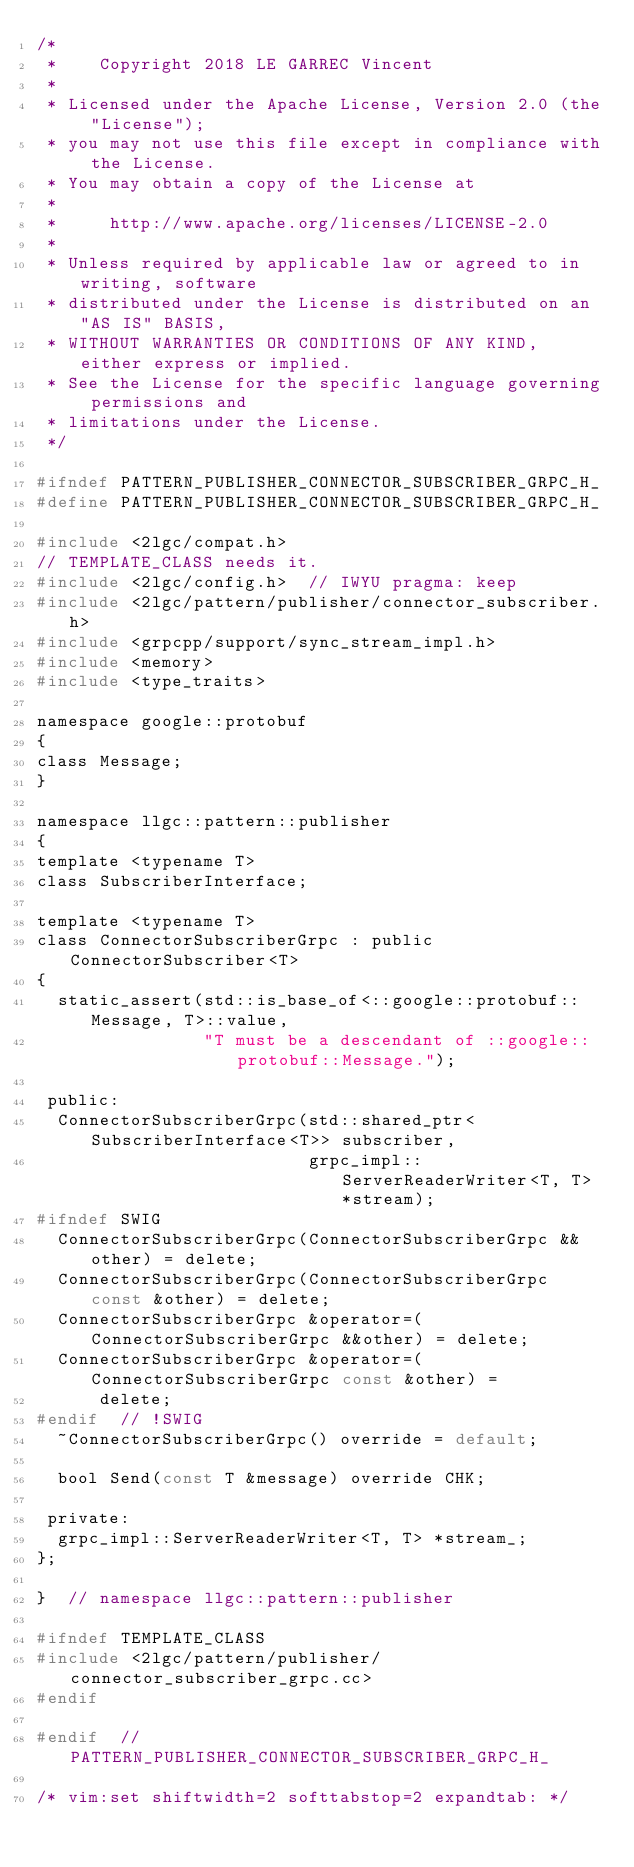<code> <loc_0><loc_0><loc_500><loc_500><_C_>/*
 *    Copyright 2018 LE GARREC Vincent
 *
 * Licensed under the Apache License, Version 2.0 (the "License");
 * you may not use this file except in compliance with the License.
 * You may obtain a copy of the License at
 *
 *     http://www.apache.org/licenses/LICENSE-2.0
 *
 * Unless required by applicable law or agreed to in writing, software
 * distributed under the License is distributed on an "AS IS" BASIS,
 * WITHOUT WARRANTIES OR CONDITIONS OF ANY KIND, either express or implied.
 * See the License for the specific language governing permissions and
 * limitations under the License.
 */

#ifndef PATTERN_PUBLISHER_CONNECTOR_SUBSCRIBER_GRPC_H_
#define PATTERN_PUBLISHER_CONNECTOR_SUBSCRIBER_GRPC_H_

#include <2lgc/compat.h>
// TEMPLATE_CLASS needs it.
#include <2lgc/config.h>  // IWYU pragma: keep
#include <2lgc/pattern/publisher/connector_subscriber.h>
#include <grpcpp/support/sync_stream_impl.h>
#include <memory>
#include <type_traits>

namespace google::protobuf
{
class Message;
}

namespace llgc::pattern::publisher
{
template <typename T>
class SubscriberInterface;

template <typename T>
class ConnectorSubscriberGrpc : public ConnectorSubscriber<T>
{
  static_assert(std::is_base_of<::google::protobuf::Message, T>::value,
                "T must be a descendant of ::google::protobuf::Message.");

 public:
  ConnectorSubscriberGrpc(std::shared_ptr<SubscriberInterface<T>> subscriber,
                          grpc_impl::ServerReaderWriter<T, T> *stream);
#ifndef SWIG
  ConnectorSubscriberGrpc(ConnectorSubscriberGrpc &&other) = delete;
  ConnectorSubscriberGrpc(ConnectorSubscriberGrpc const &other) = delete;
  ConnectorSubscriberGrpc &operator=(ConnectorSubscriberGrpc &&other) = delete;
  ConnectorSubscriberGrpc &operator=(ConnectorSubscriberGrpc const &other) =
      delete;
#endif  // !SWIG
  ~ConnectorSubscriberGrpc() override = default;

  bool Send(const T &message) override CHK;

 private:
  grpc_impl::ServerReaderWriter<T, T> *stream_;
};

}  // namespace llgc::pattern::publisher

#ifndef TEMPLATE_CLASS
#include <2lgc/pattern/publisher/connector_subscriber_grpc.cc>
#endif

#endif  // PATTERN_PUBLISHER_CONNECTOR_SUBSCRIBER_GRPC_H_

/* vim:set shiftwidth=2 softtabstop=2 expandtab: */
</code> 